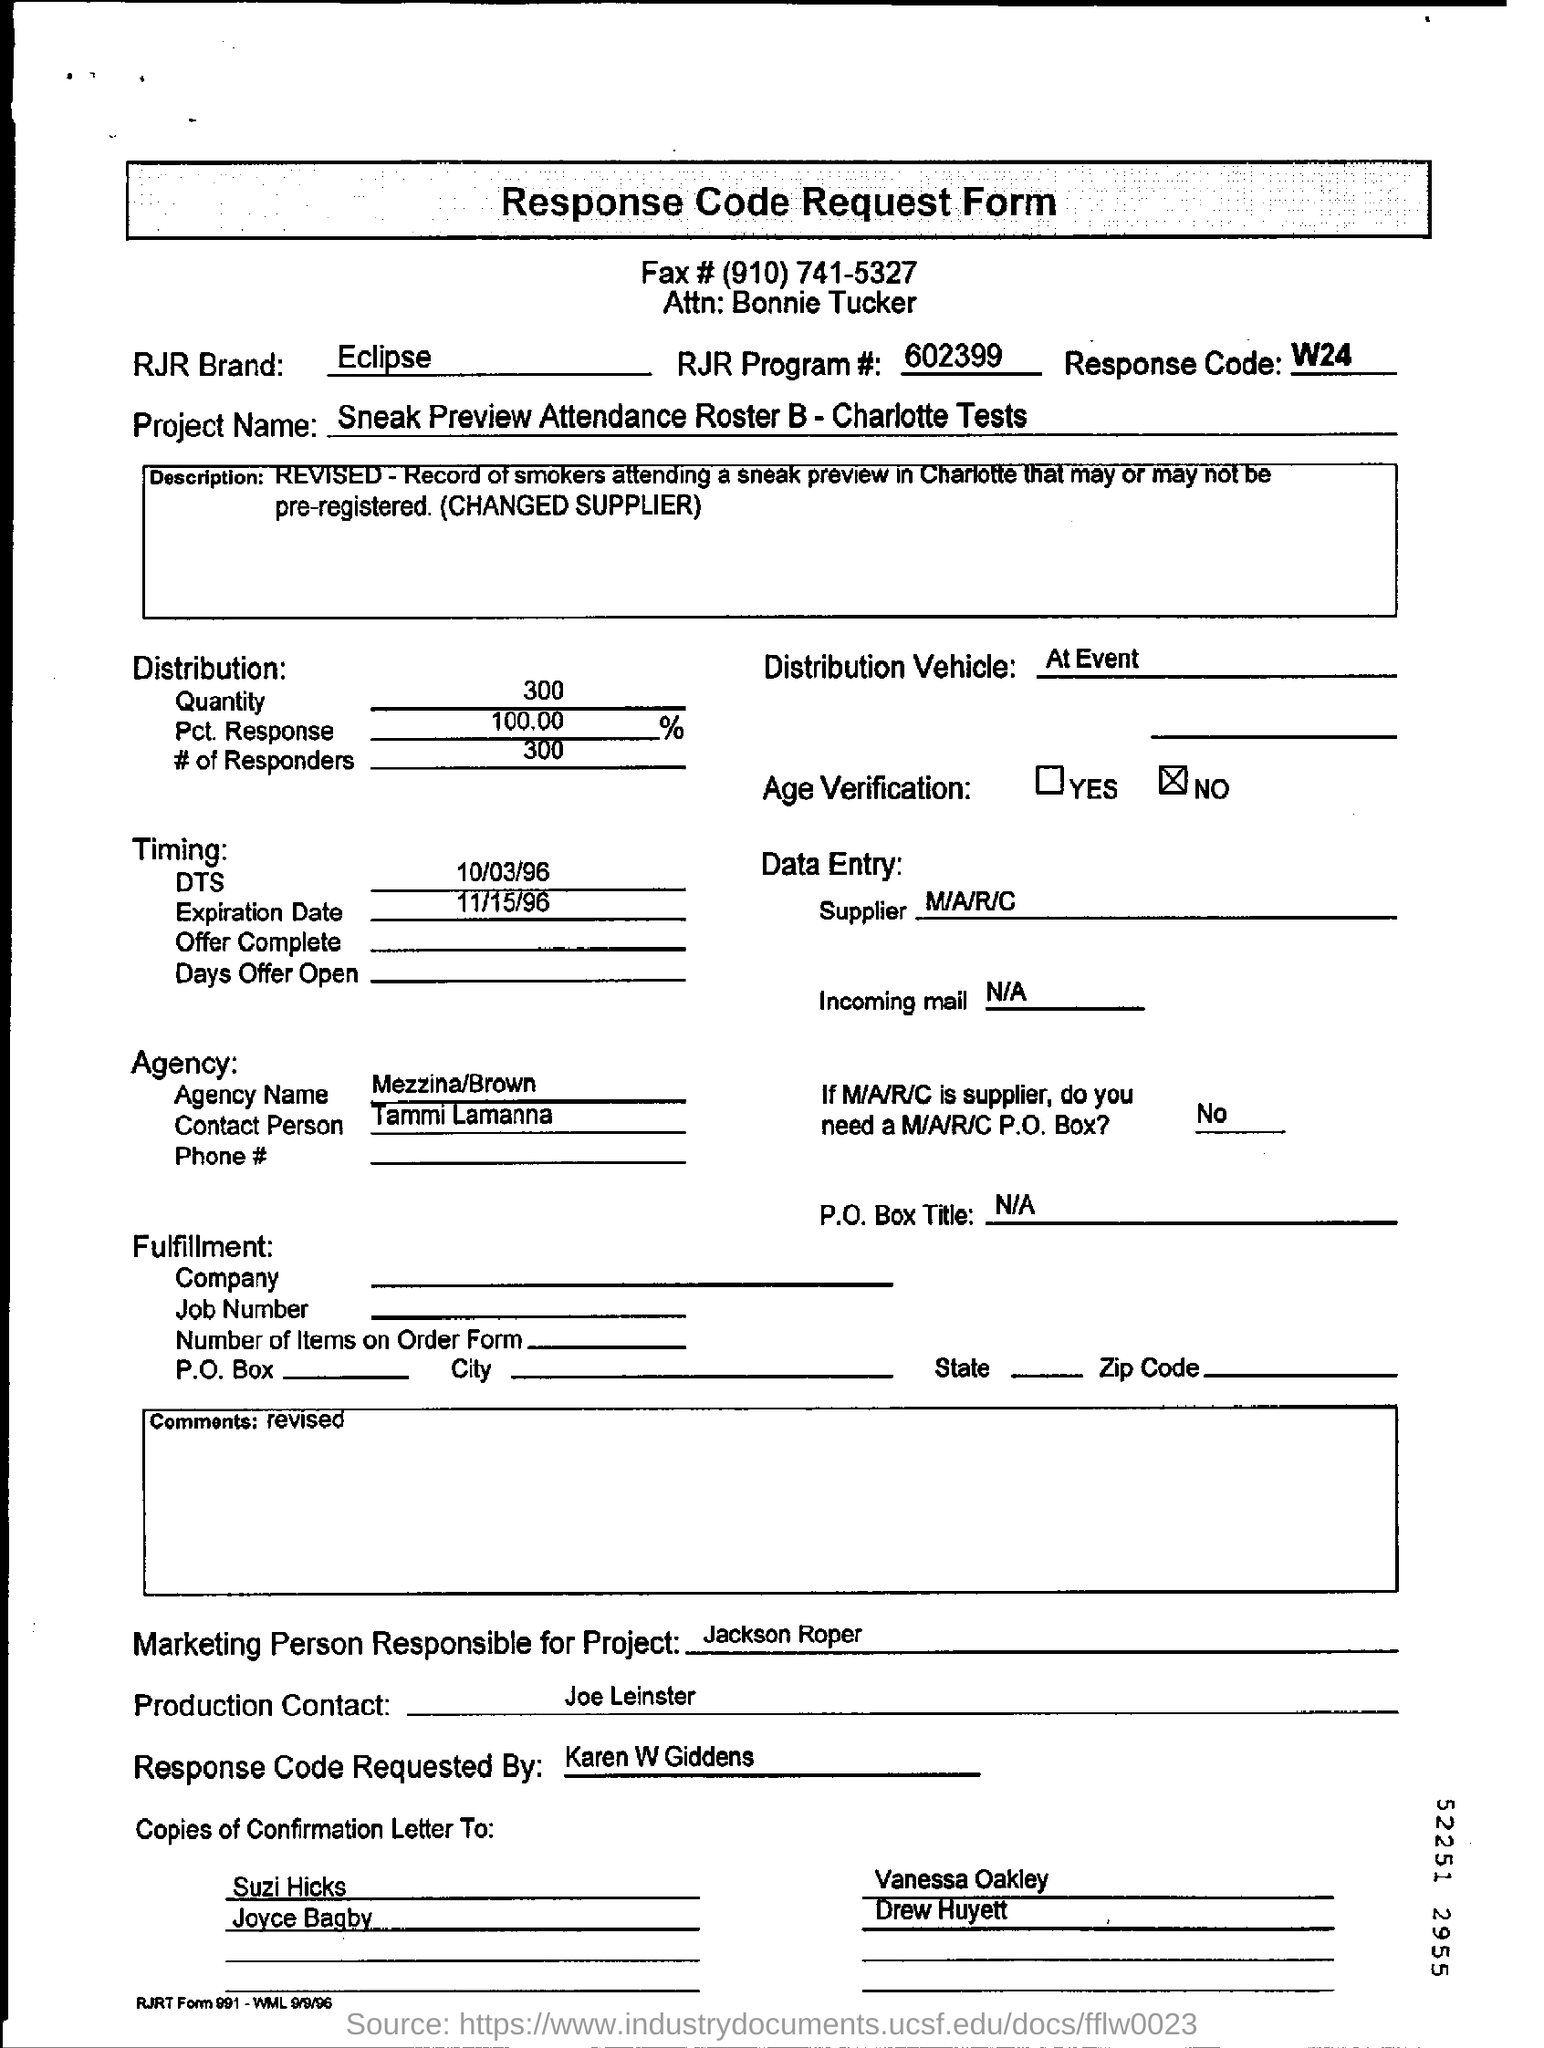Which RJR brand is mentioned?
Your answer should be compact. Eclipse. What is RJR program #?
Your answer should be very brief. 602399. What is the project name?
Give a very brief answer. Sneak Preview Attendance Roster B - Charlotte Tests. How many responders were there?
Keep it short and to the point. 300. Who requested the response code?
Make the answer very short. Karen W Giddens. 